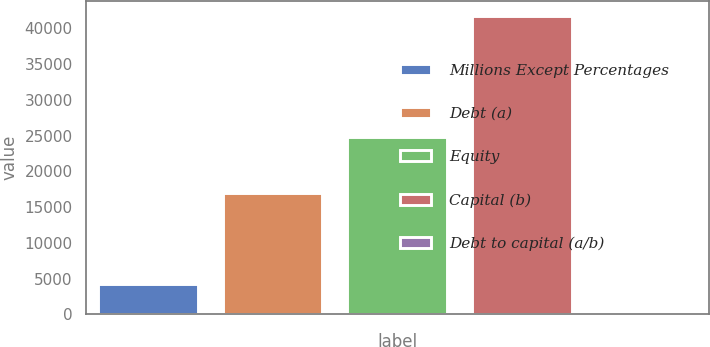<chart> <loc_0><loc_0><loc_500><loc_500><bar_chart><fcel>Millions Except Percentages<fcel>Debt (a)<fcel>Equity<fcel>Capital (b)<fcel>Debt to capital (a/b)<nl><fcel>4216.45<fcel>16944<fcel>24856<fcel>41800<fcel>40.5<nl></chart> 